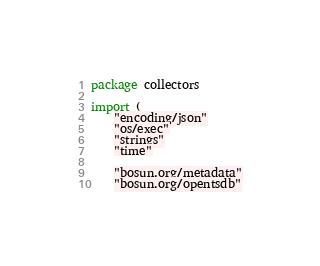Convert code to text. <code><loc_0><loc_0><loc_500><loc_500><_Go_>package collectors

import (
	"encoding/json"
	"os/exec"
	"strings"
	"time"

	"bosun.org/metadata"
	"bosun.org/opentsdb"</code> 